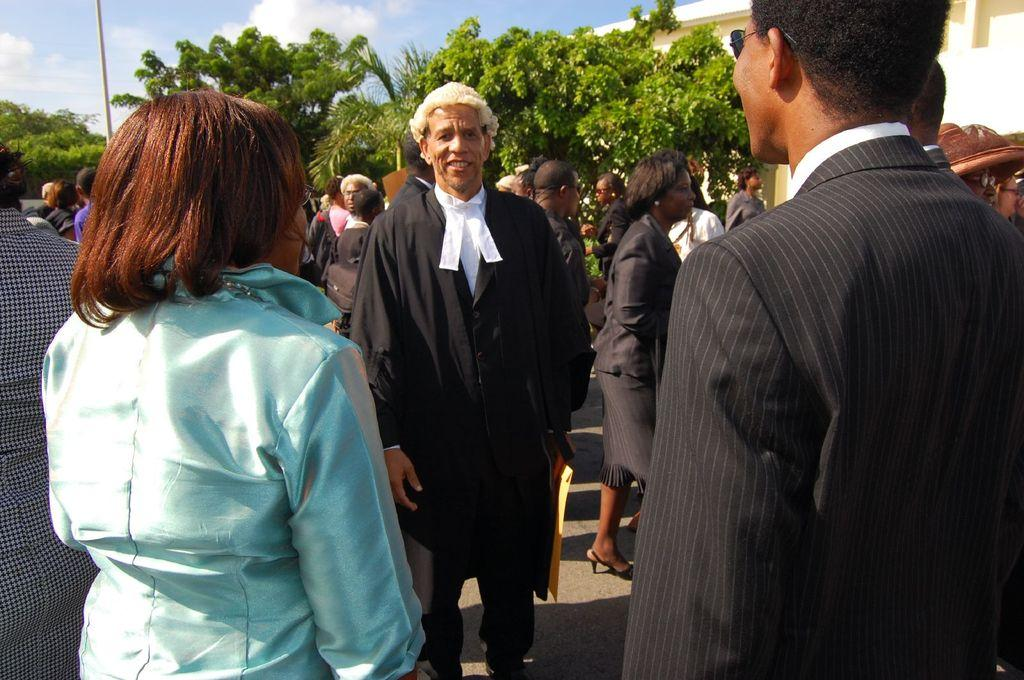What is the main subject of the image? The main subject of the image is a crowd. What can be seen in the background of the image? There are trees and a pole in the background of the image. How would you describe the sky in the image? The sky is cloudy in the image. How many feet are visible on the shelf in the image? There is no shelf or feet present in the image. What type of chess pieces can be seen on the pole in the image? There are no chess pieces or a pole with chess pieces in the image. 